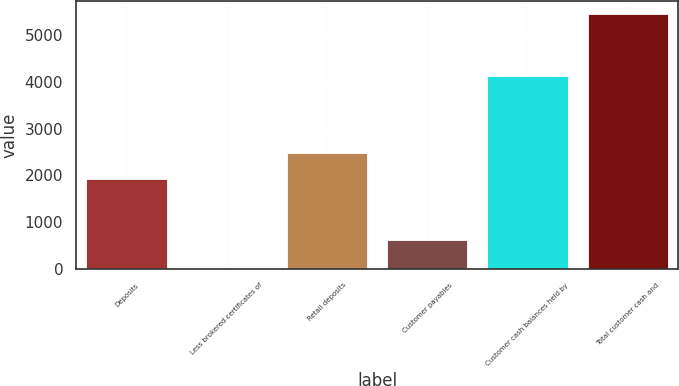<chart> <loc_0><loc_0><loc_500><loc_500><bar_chart><fcel>Deposits<fcel>Less brokered certificates of<fcel>Retail deposits<fcel>Customer payables<fcel>Customer cash balances held by<fcel>Total customer cash and<nl><fcel>1932.5<fcel>22<fcel>2475.56<fcel>626<fcel>4124.1<fcel>5452.6<nl></chart> 